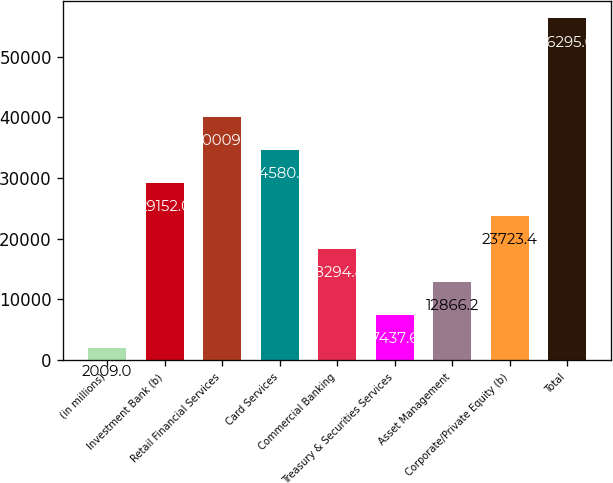Convert chart to OTSL. <chart><loc_0><loc_0><loc_500><loc_500><bar_chart><fcel>(in millions)<fcel>Investment Bank (b)<fcel>Retail Financial Services<fcel>Card Services<fcel>Commercial Banking<fcel>Treasury & Securities Services<fcel>Asset Management<fcel>Corporate/Private Equity (b)<fcel>Total<nl><fcel>2009<fcel>29152<fcel>40009.2<fcel>34580.6<fcel>18294.8<fcel>7437.6<fcel>12866.2<fcel>23723.4<fcel>56295<nl></chart> 